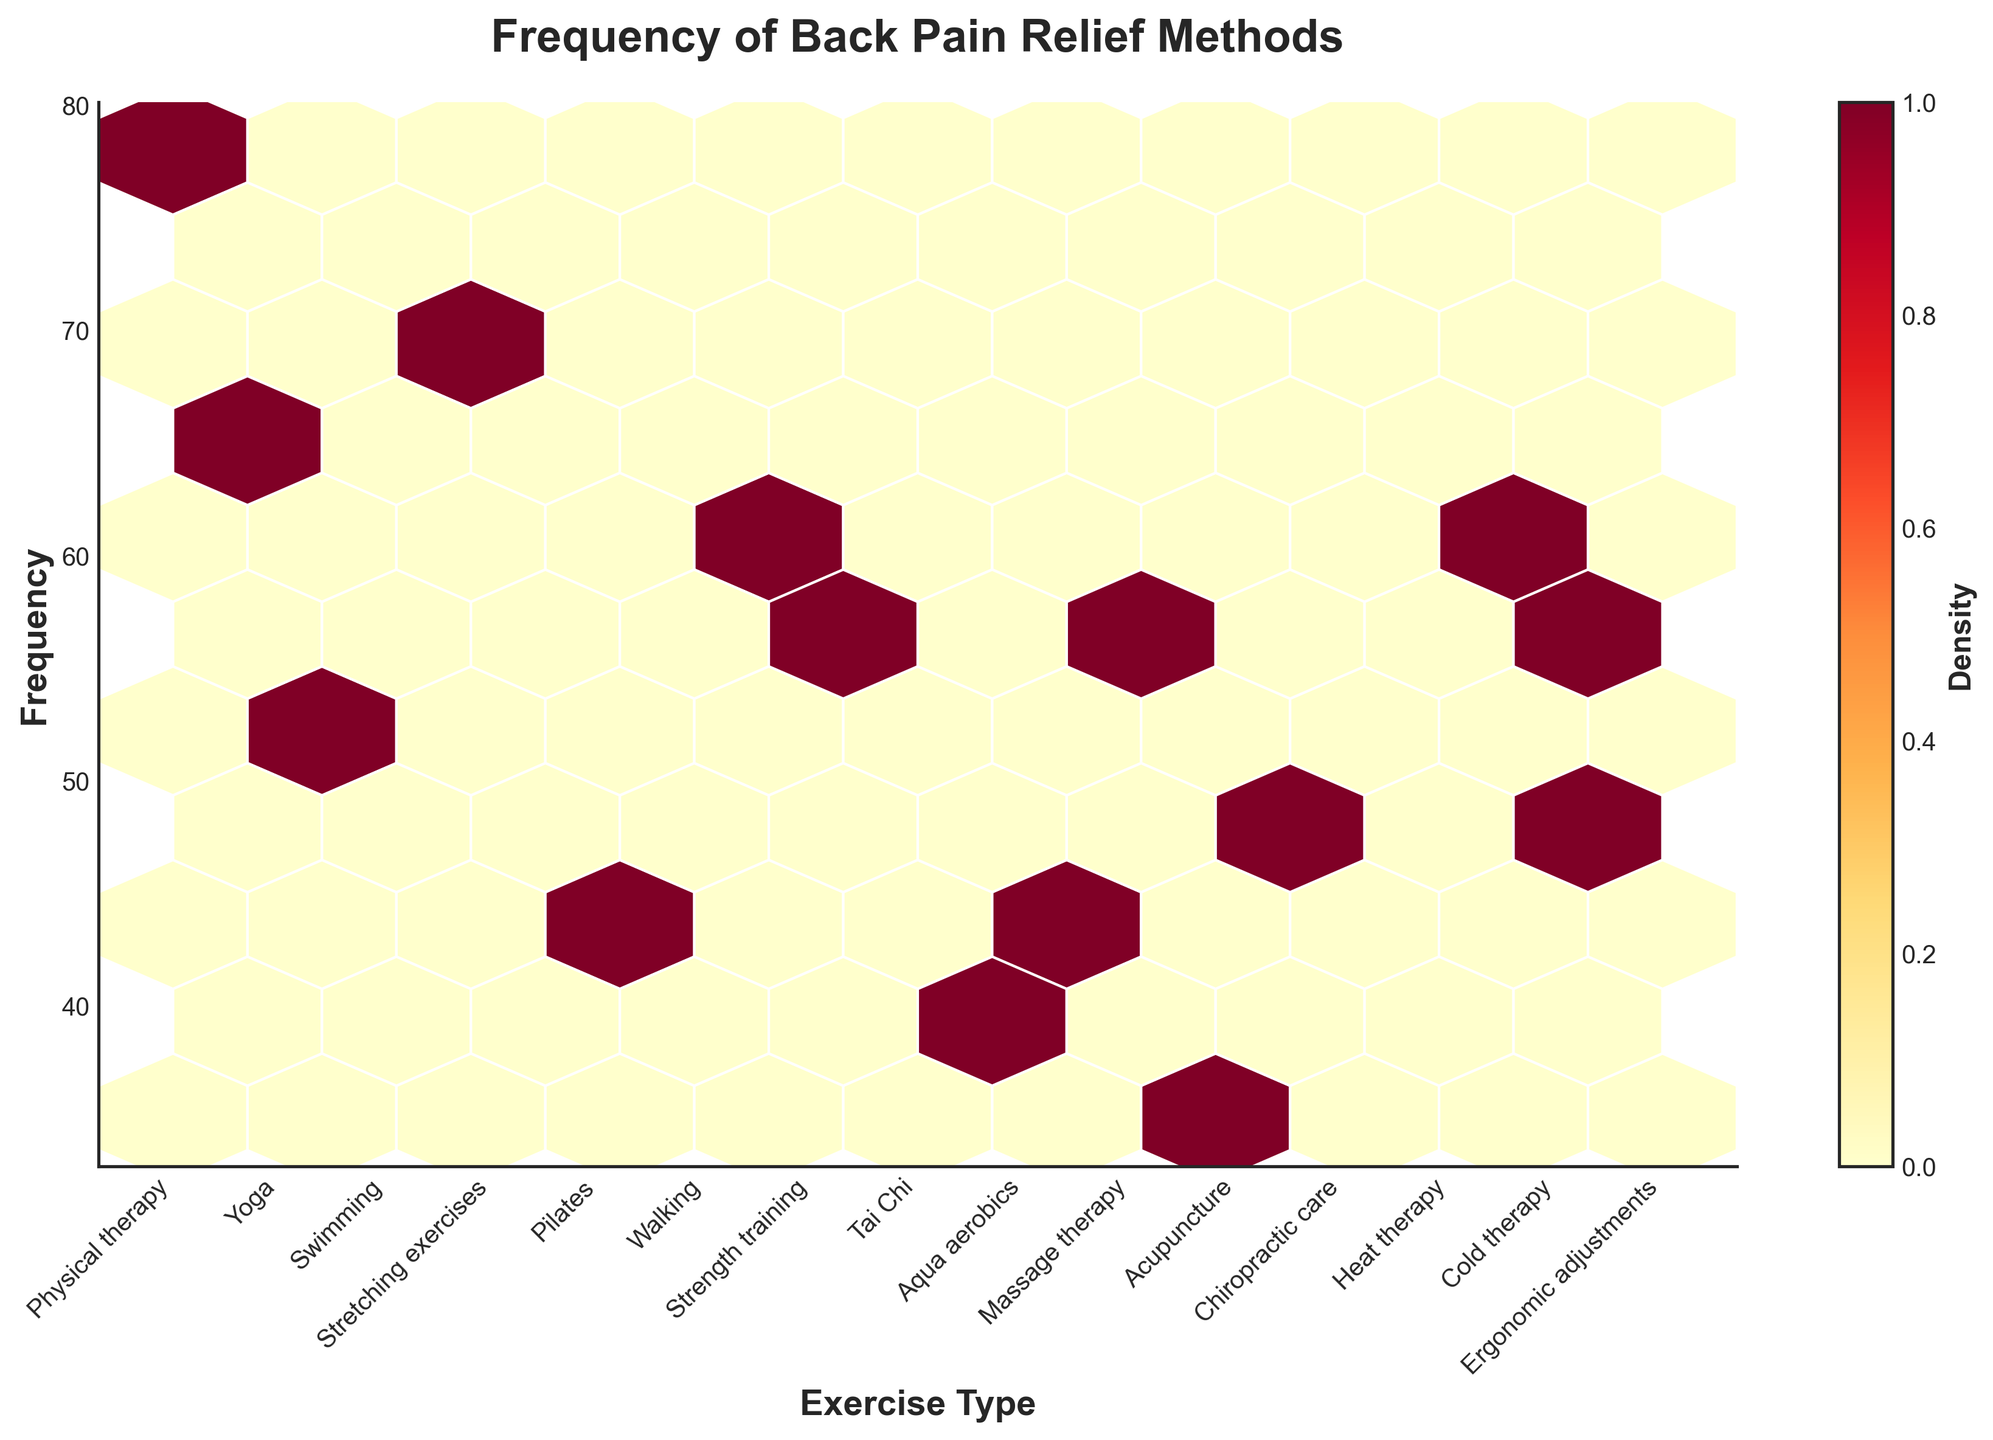What is the title of the plot? The title of the plot is usually located at the top of the figure. In this plot, it reads, "Frequency of Back Pain Relief Methods".
Answer: Frequency of Back Pain Relief Methods What do the x and y axes represent? The x-axis represents different types of exercises used for back pain relief, and the y-axis represents the frequency of how often these exercises are used. This is indicated by the labels and ticking on the axes.
Answer: Exercise Type and Frequency Which exercise type has the highest frequency in the plot? By looking at the hexbin plot and identifying the highest point on the y-axis, we find "Physical therapy" at the highest frequency of 78.
Answer: Physical therapy How does the frequency of massage therapy compare to heat therapy? By comparing the y-axis values for both "Massage therapy" and "Heat therapy", we see that Massage therapy has a frequency of 58, while Heat therapy has a frequency of 62, making Heat therapy slightly higher.
Answer: Heat therapy What is the frequency difference between acupuncture and chiropractic care? Acupuncture has a frequency of 35 and chiropractic care has a frequency of 48. The difference is calculated as 48 - 35 = 13.
Answer: 13 What are the color representations in the hexbin plot? The colors in the hexbin plot represent the density of points within each hexagon, with lighter colors indicating lower densities and darker colors representing higher densities. This is shown by the color gradient and the color bar on the right-hand side of the plot.
Answer: Density levels How many exercise types are there in the plot? By counting the ticks along the x-axis, we determine there are 15 different exercise types in the plot.
Answer: 15 What can be inferred about the popularity of Tai Chi based on the plot? From its position on the y-axis, Tai Chi has a frequency of 38, indicating it is less commonly used compared to other methods like Physical therapy or Heat therapy. This difference in height illustrates its relative popularity.
Answer: Less popular Identify the exercise type with a frequency of 55. By correlating the y-axis value of 55 with the corresponding x-axis label, we find that "Strength training" has a frequency of 55.
Answer: Strength training 